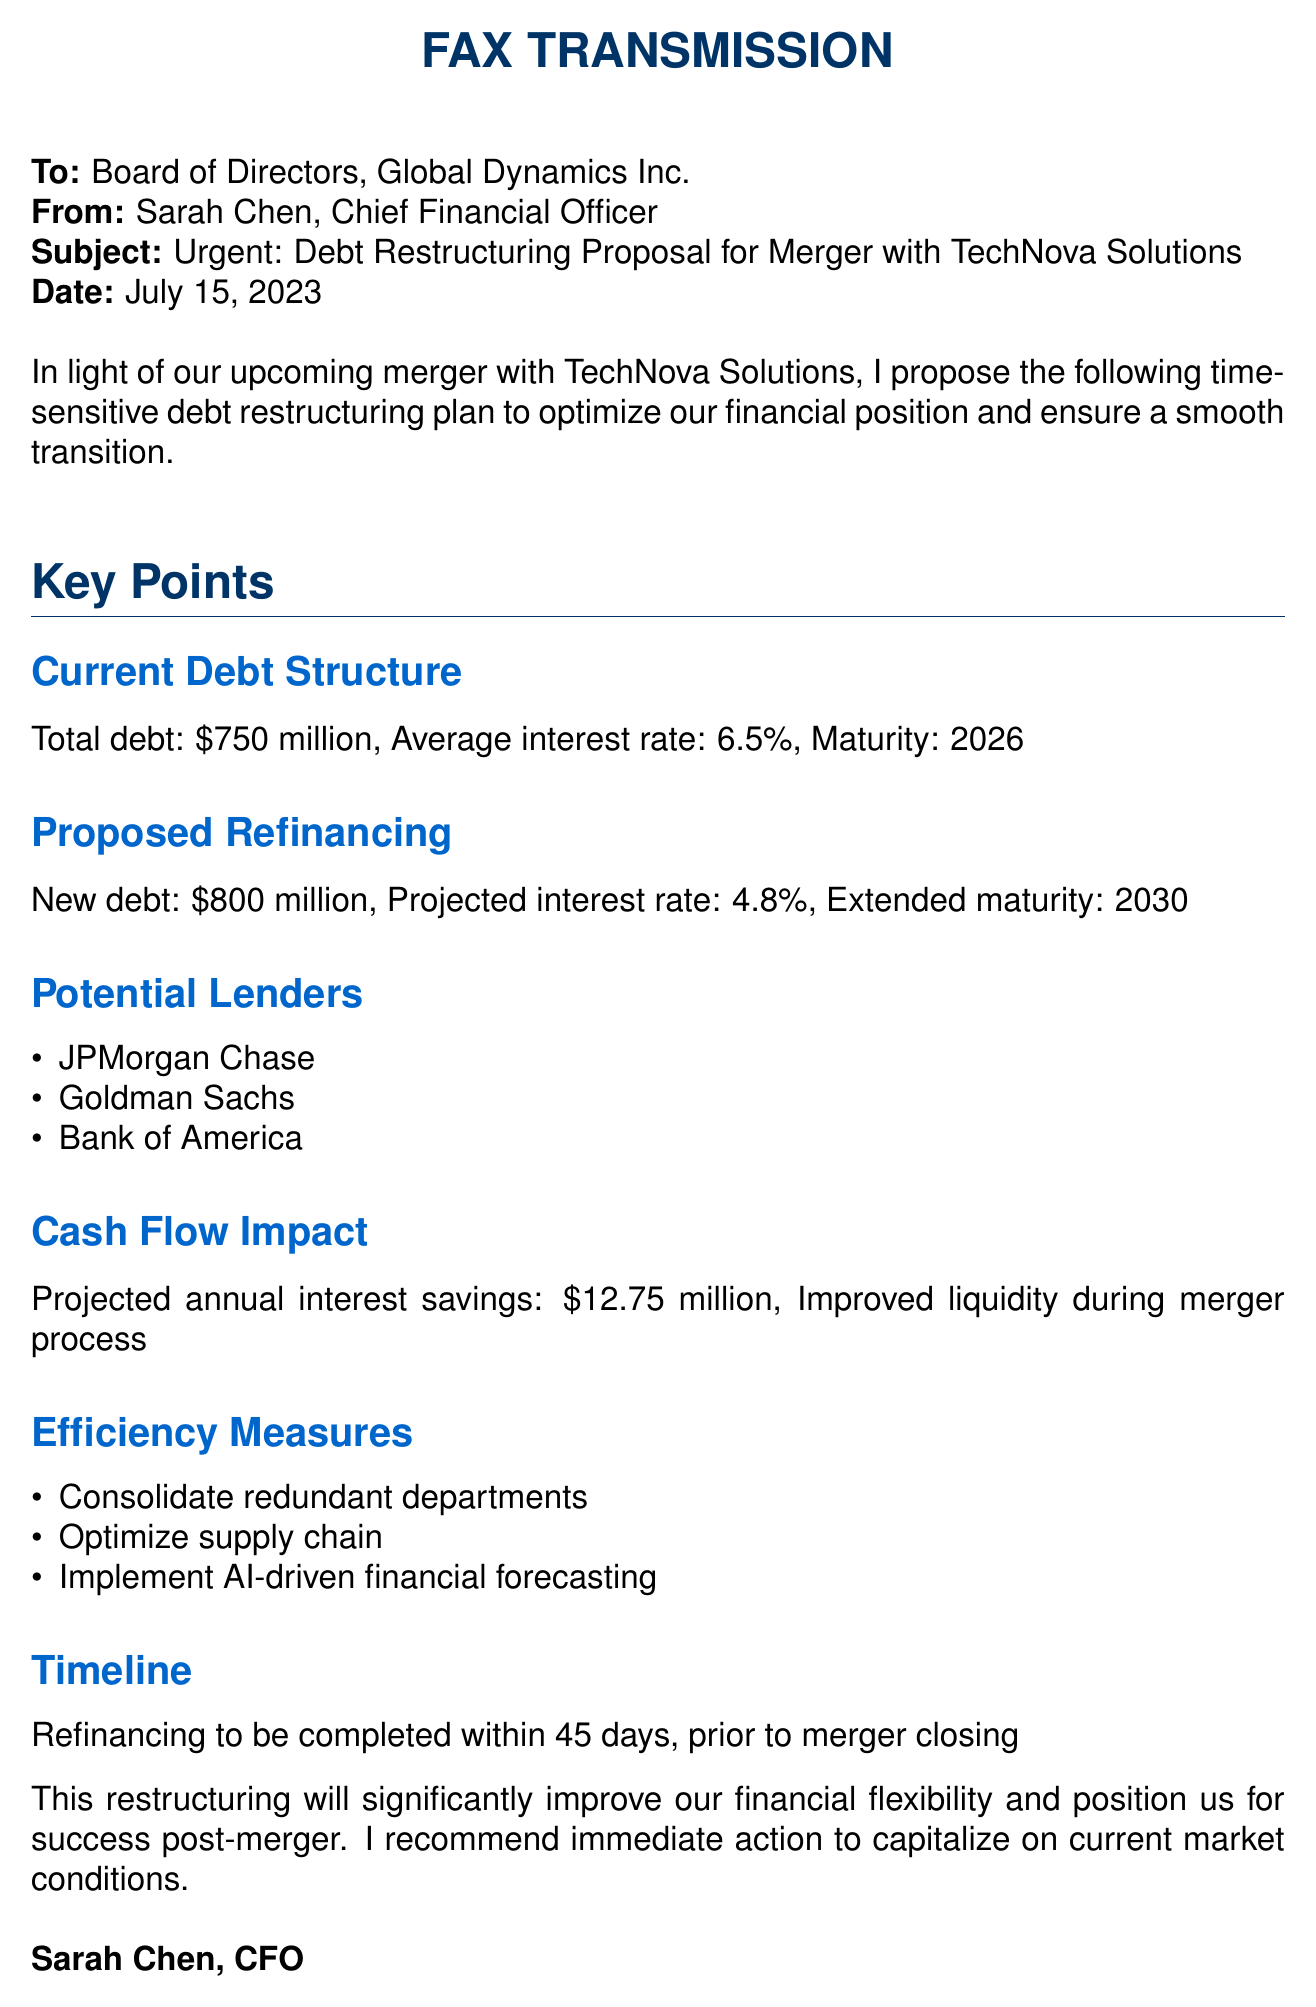What is the total debt? The total debt is stated in the document under the Current Debt Structure section.
Answer: $750 million What is the average interest rate of the current debt? The average interest rate is mentioned in the Current Debt Structure subsection.
Answer: 6.5% What is the projected interest rate after refinancing? The projected interest rate is detailed in the Proposed Refinancing section.
Answer: 4.8% Who are the potential lenders listed? The potential lenders are enumerated in the Potential Lenders subsection.
Answer: JPMorgan Chase, Goldman Sachs, Bank of America What is the projected annual interest savings from the refinancing? The projected annual interest savings is mentioned in the Cash Flow Impact section.
Answer: $12.75 million What is the new total debt proposed after refinancing? The new debt amount is found in the Proposed Refinancing subsection.
Answer: $800 million When should the refinancing be completed? The timeline for completion is specified in the Timeline section of the document.
Answer: Within 45 days What efficiency measure involves financial forecasting? One of the efficiency measures is mentioned in the Efficiency Measures subsection.
Answer: AI-driven financial forecasting What is the purpose of the proposed debt restructuring? The purpose is stated in the opening paragraph of the document.
Answer: Optimize financial position 